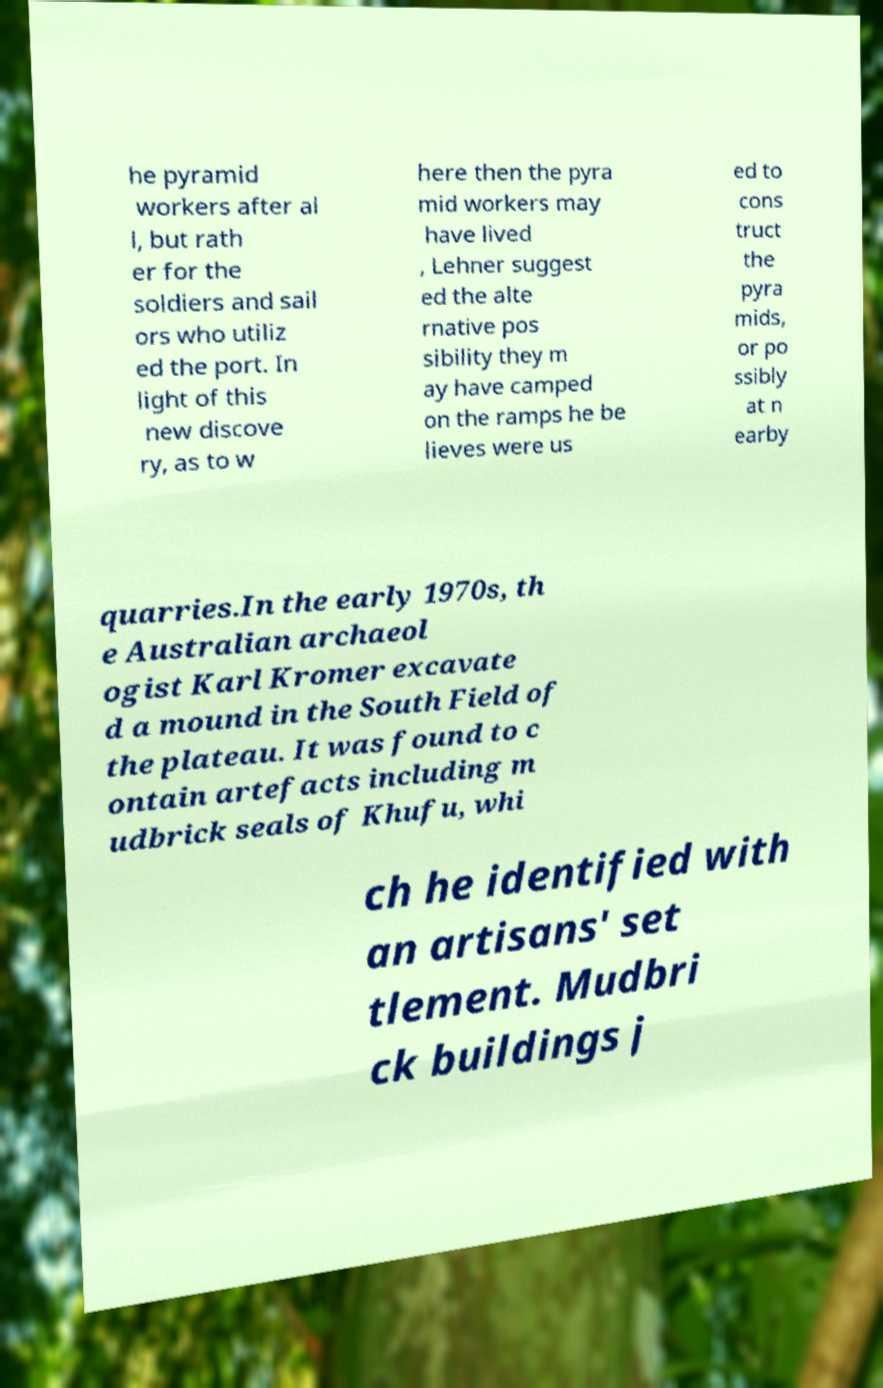What messages or text are displayed in this image? I need them in a readable, typed format. he pyramid workers after al l, but rath er for the soldiers and sail ors who utiliz ed the port. In light of this new discove ry, as to w here then the pyra mid workers may have lived , Lehner suggest ed the alte rnative pos sibility they m ay have camped on the ramps he be lieves were us ed to cons truct the pyra mids, or po ssibly at n earby quarries.In the early 1970s, th e Australian archaeol ogist Karl Kromer excavate d a mound in the South Field of the plateau. It was found to c ontain artefacts including m udbrick seals of Khufu, whi ch he identified with an artisans' set tlement. Mudbri ck buildings j 